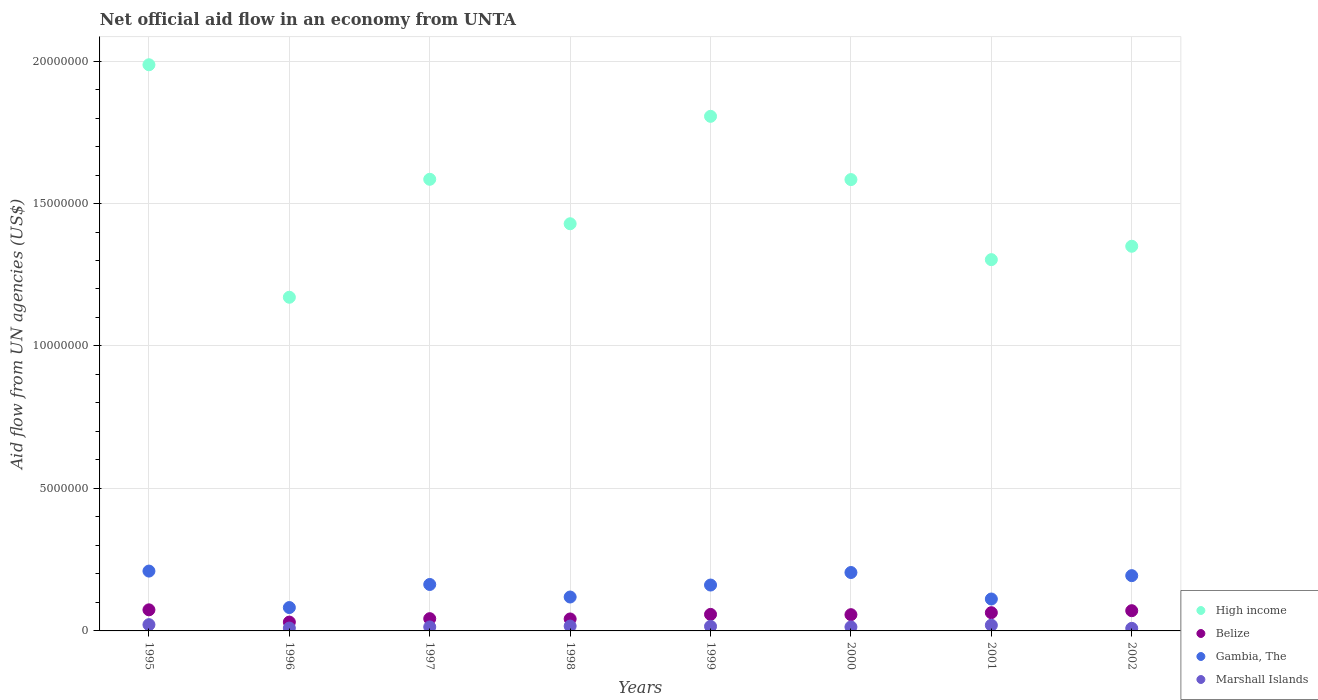How many different coloured dotlines are there?
Offer a terse response. 4. Is the number of dotlines equal to the number of legend labels?
Your answer should be very brief. Yes. What is the net official aid flow in Marshall Islands in 2000?
Provide a short and direct response. 1.40e+05. Across all years, what is the maximum net official aid flow in Gambia, The?
Give a very brief answer. 2.10e+06. Across all years, what is the minimum net official aid flow in Gambia, The?
Your answer should be compact. 8.20e+05. In which year was the net official aid flow in Gambia, The maximum?
Provide a succinct answer. 1995. What is the total net official aid flow in Marshall Islands in the graph?
Keep it short and to the point. 1.22e+06. What is the difference between the net official aid flow in High income in 1995 and that in 2001?
Keep it short and to the point. 6.84e+06. What is the difference between the net official aid flow in Gambia, The in 2002 and the net official aid flow in Belize in 1995?
Provide a short and direct response. 1.20e+06. What is the average net official aid flow in High income per year?
Offer a terse response. 1.53e+07. In the year 2002, what is the difference between the net official aid flow in Marshall Islands and net official aid flow in Gambia, The?
Your answer should be compact. -1.85e+06. What is the ratio of the net official aid flow in Marshall Islands in 1996 to that in 1997?
Provide a short and direct response. 0.71. What is the difference between the highest and the lowest net official aid flow in Marshall Islands?
Provide a succinct answer. 1.30e+05. Is the sum of the net official aid flow in Marshall Islands in 1996 and 1999 greater than the maximum net official aid flow in Gambia, The across all years?
Your response must be concise. No. Is it the case that in every year, the sum of the net official aid flow in High income and net official aid flow in Belize  is greater than the net official aid flow in Marshall Islands?
Offer a very short reply. Yes. Does the net official aid flow in High income monotonically increase over the years?
Your answer should be very brief. No. Is the net official aid flow in Belize strictly greater than the net official aid flow in Marshall Islands over the years?
Offer a terse response. Yes. Is the net official aid flow in Belize strictly less than the net official aid flow in Gambia, The over the years?
Ensure brevity in your answer.  Yes. How many dotlines are there?
Keep it short and to the point. 4. How many years are there in the graph?
Offer a terse response. 8. What is the difference between two consecutive major ticks on the Y-axis?
Provide a short and direct response. 5.00e+06. Does the graph contain grids?
Keep it short and to the point. Yes. What is the title of the graph?
Your answer should be compact. Net official aid flow in an economy from UNTA. What is the label or title of the X-axis?
Ensure brevity in your answer.  Years. What is the label or title of the Y-axis?
Provide a succinct answer. Aid flow from UN agencies (US$). What is the Aid flow from UN agencies (US$) in High income in 1995?
Make the answer very short. 1.99e+07. What is the Aid flow from UN agencies (US$) in Belize in 1995?
Offer a terse response. 7.40e+05. What is the Aid flow from UN agencies (US$) of Gambia, The in 1995?
Your answer should be very brief. 2.10e+06. What is the Aid flow from UN agencies (US$) in Marshall Islands in 1995?
Offer a terse response. 2.20e+05. What is the Aid flow from UN agencies (US$) in High income in 1996?
Provide a short and direct response. 1.17e+07. What is the Aid flow from UN agencies (US$) of Belize in 1996?
Provide a succinct answer. 3.10e+05. What is the Aid flow from UN agencies (US$) of Gambia, The in 1996?
Your answer should be compact. 8.20e+05. What is the Aid flow from UN agencies (US$) in High income in 1997?
Give a very brief answer. 1.58e+07. What is the Aid flow from UN agencies (US$) in Belize in 1997?
Provide a succinct answer. 4.30e+05. What is the Aid flow from UN agencies (US$) of Gambia, The in 1997?
Offer a terse response. 1.63e+06. What is the Aid flow from UN agencies (US$) of Marshall Islands in 1997?
Your response must be concise. 1.40e+05. What is the Aid flow from UN agencies (US$) in High income in 1998?
Your answer should be very brief. 1.43e+07. What is the Aid flow from UN agencies (US$) in Gambia, The in 1998?
Offer a very short reply. 1.19e+06. What is the Aid flow from UN agencies (US$) of High income in 1999?
Provide a succinct answer. 1.81e+07. What is the Aid flow from UN agencies (US$) in Belize in 1999?
Keep it short and to the point. 5.80e+05. What is the Aid flow from UN agencies (US$) of Gambia, The in 1999?
Ensure brevity in your answer.  1.61e+06. What is the Aid flow from UN agencies (US$) in Marshall Islands in 1999?
Provide a short and direct response. 1.60e+05. What is the Aid flow from UN agencies (US$) of High income in 2000?
Your answer should be compact. 1.58e+07. What is the Aid flow from UN agencies (US$) of Belize in 2000?
Offer a terse response. 5.70e+05. What is the Aid flow from UN agencies (US$) of Gambia, The in 2000?
Provide a succinct answer. 2.05e+06. What is the Aid flow from UN agencies (US$) of Marshall Islands in 2000?
Your answer should be compact. 1.40e+05. What is the Aid flow from UN agencies (US$) of High income in 2001?
Provide a succinct answer. 1.30e+07. What is the Aid flow from UN agencies (US$) of Belize in 2001?
Ensure brevity in your answer.  6.40e+05. What is the Aid flow from UN agencies (US$) of Gambia, The in 2001?
Give a very brief answer. 1.12e+06. What is the Aid flow from UN agencies (US$) in High income in 2002?
Give a very brief answer. 1.35e+07. What is the Aid flow from UN agencies (US$) of Belize in 2002?
Provide a succinct answer. 7.10e+05. What is the Aid flow from UN agencies (US$) of Gambia, The in 2002?
Ensure brevity in your answer.  1.94e+06. Across all years, what is the maximum Aid flow from UN agencies (US$) of High income?
Provide a short and direct response. 1.99e+07. Across all years, what is the maximum Aid flow from UN agencies (US$) of Belize?
Your answer should be very brief. 7.40e+05. Across all years, what is the maximum Aid flow from UN agencies (US$) of Gambia, The?
Provide a short and direct response. 2.10e+06. Across all years, what is the maximum Aid flow from UN agencies (US$) of Marshall Islands?
Keep it short and to the point. 2.20e+05. Across all years, what is the minimum Aid flow from UN agencies (US$) in High income?
Offer a terse response. 1.17e+07. Across all years, what is the minimum Aid flow from UN agencies (US$) in Gambia, The?
Keep it short and to the point. 8.20e+05. What is the total Aid flow from UN agencies (US$) in High income in the graph?
Your response must be concise. 1.22e+08. What is the total Aid flow from UN agencies (US$) in Belize in the graph?
Your answer should be compact. 4.40e+06. What is the total Aid flow from UN agencies (US$) in Gambia, The in the graph?
Make the answer very short. 1.25e+07. What is the total Aid flow from UN agencies (US$) in Marshall Islands in the graph?
Provide a succinct answer. 1.22e+06. What is the difference between the Aid flow from UN agencies (US$) of High income in 1995 and that in 1996?
Offer a terse response. 8.16e+06. What is the difference between the Aid flow from UN agencies (US$) of Gambia, The in 1995 and that in 1996?
Offer a very short reply. 1.28e+06. What is the difference between the Aid flow from UN agencies (US$) in Marshall Islands in 1995 and that in 1996?
Make the answer very short. 1.20e+05. What is the difference between the Aid flow from UN agencies (US$) in High income in 1995 and that in 1997?
Your answer should be compact. 4.02e+06. What is the difference between the Aid flow from UN agencies (US$) in Belize in 1995 and that in 1997?
Offer a very short reply. 3.10e+05. What is the difference between the Aid flow from UN agencies (US$) of Marshall Islands in 1995 and that in 1997?
Provide a short and direct response. 8.00e+04. What is the difference between the Aid flow from UN agencies (US$) of High income in 1995 and that in 1998?
Your response must be concise. 5.58e+06. What is the difference between the Aid flow from UN agencies (US$) of Gambia, The in 1995 and that in 1998?
Keep it short and to the point. 9.10e+05. What is the difference between the Aid flow from UN agencies (US$) of High income in 1995 and that in 1999?
Your answer should be very brief. 1.81e+06. What is the difference between the Aid flow from UN agencies (US$) of Belize in 1995 and that in 1999?
Provide a succinct answer. 1.60e+05. What is the difference between the Aid flow from UN agencies (US$) of High income in 1995 and that in 2000?
Ensure brevity in your answer.  4.03e+06. What is the difference between the Aid flow from UN agencies (US$) of Gambia, The in 1995 and that in 2000?
Offer a terse response. 5.00e+04. What is the difference between the Aid flow from UN agencies (US$) in Marshall Islands in 1995 and that in 2000?
Provide a short and direct response. 8.00e+04. What is the difference between the Aid flow from UN agencies (US$) of High income in 1995 and that in 2001?
Your answer should be compact. 6.84e+06. What is the difference between the Aid flow from UN agencies (US$) of Gambia, The in 1995 and that in 2001?
Give a very brief answer. 9.80e+05. What is the difference between the Aid flow from UN agencies (US$) of Marshall Islands in 1995 and that in 2001?
Give a very brief answer. 2.00e+04. What is the difference between the Aid flow from UN agencies (US$) of High income in 1995 and that in 2002?
Your response must be concise. 6.37e+06. What is the difference between the Aid flow from UN agencies (US$) in Belize in 1995 and that in 2002?
Your answer should be compact. 3.00e+04. What is the difference between the Aid flow from UN agencies (US$) in High income in 1996 and that in 1997?
Provide a short and direct response. -4.14e+06. What is the difference between the Aid flow from UN agencies (US$) of Gambia, The in 1996 and that in 1997?
Give a very brief answer. -8.10e+05. What is the difference between the Aid flow from UN agencies (US$) of Marshall Islands in 1996 and that in 1997?
Ensure brevity in your answer.  -4.00e+04. What is the difference between the Aid flow from UN agencies (US$) of High income in 1996 and that in 1998?
Offer a terse response. -2.58e+06. What is the difference between the Aid flow from UN agencies (US$) in Gambia, The in 1996 and that in 1998?
Give a very brief answer. -3.70e+05. What is the difference between the Aid flow from UN agencies (US$) in High income in 1996 and that in 1999?
Your response must be concise. -6.35e+06. What is the difference between the Aid flow from UN agencies (US$) in Belize in 1996 and that in 1999?
Your answer should be compact. -2.70e+05. What is the difference between the Aid flow from UN agencies (US$) in Gambia, The in 1996 and that in 1999?
Offer a very short reply. -7.90e+05. What is the difference between the Aid flow from UN agencies (US$) in Marshall Islands in 1996 and that in 1999?
Your response must be concise. -6.00e+04. What is the difference between the Aid flow from UN agencies (US$) in High income in 1996 and that in 2000?
Give a very brief answer. -4.13e+06. What is the difference between the Aid flow from UN agencies (US$) in Belize in 1996 and that in 2000?
Provide a short and direct response. -2.60e+05. What is the difference between the Aid flow from UN agencies (US$) of Gambia, The in 1996 and that in 2000?
Your response must be concise. -1.23e+06. What is the difference between the Aid flow from UN agencies (US$) in Marshall Islands in 1996 and that in 2000?
Your answer should be compact. -4.00e+04. What is the difference between the Aid flow from UN agencies (US$) of High income in 1996 and that in 2001?
Your answer should be very brief. -1.32e+06. What is the difference between the Aid flow from UN agencies (US$) in Belize in 1996 and that in 2001?
Make the answer very short. -3.30e+05. What is the difference between the Aid flow from UN agencies (US$) of Gambia, The in 1996 and that in 2001?
Offer a terse response. -3.00e+05. What is the difference between the Aid flow from UN agencies (US$) of Marshall Islands in 1996 and that in 2001?
Offer a terse response. -1.00e+05. What is the difference between the Aid flow from UN agencies (US$) of High income in 1996 and that in 2002?
Your answer should be compact. -1.79e+06. What is the difference between the Aid flow from UN agencies (US$) in Belize in 1996 and that in 2002?
Make the answer very short. -4.00e+05. What is the difference between the Aid flow from UN agencies (US$) of Gambia, The in 1996 and that in 2002?
Your answer should be very brief. -1.12e+06. What is the difference between the Aid flow from UN agencies (US$) in Marshall Islands in 1996 and that in 2002?
Ensure brevity in your answer.  10000. What is the difference between the Aid flow from UN agencies (US$) in High income in 1997 and that in 1998?
Offer a very short reply. 1.56e+06. What is the difference between the Aid flow from UN agencies (US$) of High income in 1997 and that in 1999?
Offer a very short reply. -2.21e+06. What is the difference between the Aid flow from UN agencies (US$) of Belize in 1997 and that in 1999?
Provide a short and direct response. -1.50e+05. What is the difference between the Aid flow from UN agencies (US$) in High income in 1997 and that in 2000?
Offer a terse response. 10000. What is the difference between the Aid flow from UN agencies (US$) of Belize in 1997 and that in 2000?
Your answer should be compact. -1.40e+05. What is the difference between the Aid flow from UN agencies (US$) in Gambia, The in 1997 and that in 2000?
Ensure brevity in your answer.  -4.20e+05. What is the difference between the Aid flow from UN agencies (US$) in High income in 1997 and that in 2001?
Provide a short and direct response. 2.82e+06. What is the difference between the Aid flow from UN agencies (US$) of Belize in 1997 and that in 2001?
Ensure brevity in your answer.  -2.10e+05. What is the difference between the Aid flow from UN agencies (US$) of Gambia, The in 1997 and that in 2001?
Keep it short and to the point. 5.10e+05. What is the difference between the Aid flow from UN agencies (US$) in High income in 1997 and that in 2002?
Give a very brief answer. 2.35e+06. What is the difference between the Aid flow from UN agencies (US$) of Belize in 1997 and that in 2002?
Provide a short and direct response. -2.80e+05. What is the difference between the Aid flow from UN agencies (US$) in Gambia, The in 1997 and that in 2002?
Ensure brevity in your answer.  -3.10e+05. What is the difference between the Aid flow from UN agencies (US$) in High income in 1998 and that in 1999?
Your answer should be compact. -3.77e+06. What is the difference between the Aid flow from UN agencies (US$) of Belize in 1998 and that in 1999?
Your response must be concise. -1.60e+05. What is the difference between the Aid flow from UN agencies (US$) of Gambia, The in 1998 and that in 1999?
Offer a very short reply. -4.20e+05. What is the difference between the Aid flow from UN agencies (US$) of Marshall Islands in 1998 and that in 1999?
Make the answer very short. 10000. What is the difference between the Aid flow from UN agencies (US$) in High income in 1998 and that in 2000?
Give a very brief answer. -1.55e+06. What is the difference between the Aid flow from UN agencies (US$) in Belize in 1998 and that in 2000?
Provide a succinct answer. -1.50e+05. What is the difference between the Aid flow from UN agencies (US$) of Gambia, The in 1998 and that in 2000?
Your response must be concise. -8.60e+05. What is the difference between the Aid flow from UN agencies (US$) in Marshall Islands in 1998 and that in 2000?
Provide a short and direct response. 3.00e+04. What is the difference between the Aid flow from UN agencies (US$) in High income in 1998 and that in 2001?
Make the answer very short. 1.26e+06. What is the difference between the Aid flow from UN agencies (US$) of Belize in 1998 and that in 2001?
Provide a short and direct response. -2.20e+05. What is the difference between the Aid flow from UN agencies (US$) in Marshall Islands in 1998 and that in 2001?
Offer a terse response. -3.00e+04. What is the difference between the Aid flow from UN agencies (US$) in High income in 1998 and that in 2002?
Your response must be concise. 7.90e+05. What is the difference between the Aid flow from UN agencies (US$) in Gambia, The in 1998 and that in 2002?
Provide a short and direct response. -7.50e+05. What is the difference between the Aid flow from UN agencies (US$) of High income in 1999 and that in 2000?
Offer a terse response. 2.22e+06. What is the difference between the Aid flow from UN agencies (US$) of Gambia, The in 1999 and that in 2000?
Ensure brevity in your answer.  -4.40e+05. What is the difference between the Aid flow from UN agencies (US$) of Marshall Islands in 1999 and that in 2000?
Provide a succinct answer. 2.00e+04. What is the difference between the Aid flow from UN agencies (US$) of High income in 1999 and that in 2001?
Make the answer very short. 5.03e+06. What is the difference between the Aid flow from UN agencies (US$) in Belize in 1999 and that in 2001?
Your answer should be compact. -6.00e+04. What is the difference between the Aid flow from UN agencies (US$) in Marshall Islands in 1999 and that in 2001?
Your answer should be compact. -4.00e+04. What is the difference between the Aid flow from UN agencies (US$) of High income in 1999 and that in 2002?
Your answer should be very brief. 4.56e+06. What is the difference between the Aid flow from UN agencies (US$) of Gambia, The in 1999 and that in 2002?
Provide a short and direct response. -3.30e+05. What is the difference between the Aid flow from UN agencies (US$) in High income in 2000 and that in 2001?
Your response must be concise. 2.81e+06. What is the difference between the Aid flow from UN agencies (US$) in Belize in 2000 and that in 2001?
Offer a very short reply. -7.00e+04. What is the difference between the Aid flow from UN agencies (US$) in Gambia, The in 2000 and that in 2001?
Ensure brevity in your answer.  9.30e+05. What is the difference between the Aid flow from UN agencies (US$) of Marshall Islands in 2000 and that in 2001?
Provide a succinct answer. -6.00e+04. What is the difference between the Aid flow from UN agencies (US$) in High income in 2000 and that in 2002?
Provide a short and direct response. 2.34e+06. What is the difference between the Aid flow from UN agencies (US$) of Belize in 2000 and that in 2002?
Your answer should be compact. -1.40e+05. What is the difference between the Aid flow from UN agencies (US$) in Gambia, The in 2000 and that in 2002?
Provide a succinct answer. 1.10e+05. What is the difference between the Aid flow from UN agencies (US$) in High income in 2001 and that in 2002?
Your response must be concise. -4.70e+05. What is the difference between the Aid flow from UN agencies (US$) in Gambia, The in 2001 and that in 2002?
Make the answer very short. -8.20e+05. What is the difference between the Aid flow from UN agencies (US$) of Marshall Islands in 2001 and that in 2002?
Your answer should be compact. 1.10e+05. What is the difference between the Aid flow from UN agencies (US$) in High income in 1995 and the Aid flow from UN agencies (US$) in Belize in 1996?
Your answer should be compact. 1.96e+07. What is the difference between the Aid flow from UN agencies (US$) in High income in 1995 and the Aid flow from UN agencies (US$) in Gambia, The in 1996?
Give a very brief answer. 1.90e+07. What is the difference between the Aid flow from UN agencies (US$) in High income in 1995 and the Aid flow from UN agencies (US$) in Marshall Islands in 1996?
Keep it short and to the point. 1.98e+07. What is the difference between the Aid flow from UN agencies (US$) of Belize in 1995 and the Aid flow from UN agencies (US$) of Gambia, The in 1996?
Make the answer very short. -8.00e+04. What is the difference between the Aid flow from UN agencies (US$) of Belize in 1995 and the Aid flow from UN agencies (US$) of Marshall Islands in 1996?
Ensure brevity in your answer.  6.40e+05. What is the difference between the Aid flow from UN agencies (US$) of High income in 1995 and the Aid flow from UN agencies (US$) of Belize in 1997?
Provide a succinct answer. 1.94e+07. What is the difference between the Aid flow from UN agencies (US$) in High income in 1995 and the Aid flow from UN agencies (US$) in Gambia, The in 1997?
Provide a succinct answer. 1.82e+07. What is the difference between the Aid flow from UN agencies (US$) of High income in 1995 and the Aid flow from UN agencies (US$) of Marshall Islands in 1997?
Your answer should be compact. 1.97e+07. What is the difference between the Aid flow from UN agencies (US$) of Belize in 1995 and the Aid flow from UN agencies (US$) of Gambia, The in 1997?
Give a very brief answer. -8.90e+05. What is the difference between the Aid flow from UN agencies (US$) in Belize in 1995 and the Aid flow from UN agencies (US$) in Marshall Islands in 1997?
Offer a terse response. 6.00e+05. What is the difference between the Aid flow from UN agencies (US$) in Gambia, The in 1995 and the Aid flow from UN agencies (US$) in Marshall Islands in 1997?
Your response must be concise. 1.96e+06. What is the difference between the Aid flow from UN agencies (US$) of High income in 1995 and the Aid flow from UN agencies (US$) of Belize in 1998?
Ensure brevity in your answer.  1.94e+07. What is the difference between the Aid flow from UN agencies (US$) in High income in 1995 and the Aid flow from UN agencies (US$) in Gambia, The in 1998?
Ensure brevity in your answer.  1.87e+07. What is the difference between the Aid flow from UN agencies (US$) of High income in 1995 and the Aid flow from UN agencies (US$) of Marshall Islands in 1998?
Offer a terse response. 1.97e+07. What is the difference between the Aid flow from UN agencies (US$) of Belize in 1995 and the Aid flow from UN agencies (US$) of Gambia, The in 1998?
Your response must be concise. -4.50e+05. What is the difference between the Aid flow from UN agencies (US$) in Belize in 1995 and the Aid flow from UN agencies (US$) in Marshall Islands in 1998?
Make the answer very short. 5.70e+05. What is the difference between the Aid flow from UN agencies (US$) of Gambia, The in 1995 and the Aid flow from UN agencies (US$) of Marshall Islands in 1998?
Provide a short and direct response. 1.93e+06. What is the difference between the Aid flow from UN agencies (US$) in High income in 1995 and the Aid flow from UN agencies (US$) in Belize in 1999?
Ensure brevity in your answer.  1.93e+07. What is the difference between the Aid flow from UN agencies (US$) of High income in 1995 and the Aid flow from UN agencies (US$) of Gambia, The in 1999?
Give a very brief answer. 1.83e+07. What is the difference between the Aid flow from UN agencies (US$) of High income in 1995 and the Aid flow from UN agencies (US$) of Marshall Islands in 1999?
Make the answer very short. 1.97e+07. What is the difference between the Aid flow from UN agencies (US$) of Belize in 1995 and the Aid flow from UN agencies (US$) of Gambia, The in 1999?
Make the answer very short. -8.70e+05. What is the difference between the Aid flow from UN agencies (US$) in Belize in 1995 and the Aid flow from UN agencies (US$) in Marshall Islands in 1999?
Make the answer very short. 5.80e+05. What is the difference between the Aid flow from UN agencies (US$) of Gambia, The in 1995 and the Aid flow from UN agencies (US$) of Marshall Islands in 1999?
Offer a very short reply. 1.94e+06. What is the difference between the Aid flow from UN agencies (US$) in High income in 1995 and the Aid flow from UN agencies (US$) in Belize in 2000?
Your answer should be very brief. 1.93e+07. What is the difference between the Aid flow from UN agencies (US$) in High income in 1995 and the Aid flow from UN agencies (US$) in Gambia, The in 2000?
Provide a succinct answer. 1.78e+07. What is the difference between the Aid flow from UN agencies (US$) in High income in 1995 and the Aid flow from UN agencies (US$) in Marshall Islands in 2000?
Give a very brief answer. 1.97e+07. What is the difference between the Aid flow from UN agencies (US$) in Belize in 1995 and the Aid flow from UN agencies (US$) in Gambia, The in 2000?
Give a very brief answer. -1.31e+06. What is the difference between the Aid flow from UN agencies (US$) of Belize in 1995 and the Aid flow from UN agencies (US$) of Marshall Islands in 2000?
Make the answer very short. 6.00e+05. What is the difference between the Aid flow from UN agencies (US$) in Gambia, The in 1995 and the Aid flow from UN agencies (US$) in Marshall Islands in 2000?
Make the answer very short. 1.96e+06. What is the difference between the Aid flow from UN agencies (US$) of High income in 1995 and the Aid flow from UN agencies (US$) of Belize in 2001?
Your response must be concise. 1.92e+07. What is the difference between the Aid flow from UN agencies (US$) of High income in 1995 and the Aid flow from UN agencies (US$) of Gambia, The in 2001?
Keep it short and to the point. 1.88e+07. What is the difference between the Aid flow from UN agencies (US$) of High income in 1995 and the Aid flow from UN agencies (US$) of Marshall Islands in 2001?
Give a very brief answer. 1.97e+07. What is the difference between the Aid flow from UN agencies (US$) of Belize in 1995 and the Aid flow from UN agencies (US$) of Gambia, The in 2001?
Your response must be concise. -3.80e+05. What is the difference between the Aid flow from UN agencies (US$) of Belize in 1995 and the Aid flow from UN agencies (US$) of Marshall Islands in 2001?
Ensure brevity in your answer.  5.40e+05. What is the difference between the Aid flow from UN agencies (US$) of Gambia, The in 1995 and the Aid flow from UN agencies (US$) of Marshall Islands in 2001?
Make the answer very short. 1.90e+06. What is the difference between the Aid flow from UN agencies (US$) in High income in 1995 and the Aid flow from UN agencies (US$) in Belize in 2002?
Offer a terse response. 1.92e+07. What is the difference between the Aid flow from UN agencies (US$) in High income in 1995 and the Aid flow from UN agencies (US$) in Gambia, The in 2002?
Ensure brevity in your answer.  1.79e+07. What is the difference between the Aid flow from UN agencies (US$) in High income in 1995 and the Aid flow from UN agencies (US$) in Marshall Islands in 2002?
Your response must be concise. 1.98e+07. What is the difference between the Aid flow from UN agencies (US$) in Belize in 1995 and the Aid flow from UN agencies (US$) in Gambia, The in 2002?
Provide a succinct answer. -1.20e+06. What is the difference between the Aid flow from UN agencies (US$) in Belize in 1995 and the Aid flow from UN agencies (US$) in Marshall Islands in 2002?
Keep it short and to the point. 6.50e+05. What is the difference between the Aid flow from UN agencies (US$) of Gambia, The in 1995 and the Aid flow from UN agencies (US$) of Marshall Islands in 2002?
Offer a very short reply. 2.01e+06. What is the difference between the Aid flow from UN agencies (US$) of High income in 1996 and the Aid flow from UN agencies (US$) of Belize in 1997?
Provide a short and direct response. 1.13e+07. What is the difference between the Aid flow from UN agencies (US$) of High income in 1996 and the Aid flow from UN agencies (US$) of Gambia, The in 1997?
Provide a succinct answer. 1.01e+07. What is the difference between the Aid flow from UN agencies (US$) of High income in 1996 and the Aid flow from UN agencies (US$) of Marshall Islands in 1997?
Offer a very short reply. 1.16e+07. What is the difference between the Aid flow from UN agencies (US$) of Belize in 1996 and the Aid flow from UN agencies (US$) of Gambia, The in 1997?
Your response must be concise. -1.32e+06. What is the difference between the Aid flow from UN agencies (US$) in Belize in 1996 and the Aid flow from UN agencies (US$) in Marshall Islands in 1997?
Your answer should be very brief. 1.70e+05. What is the difference between the Aid flow from UN agencies (US$) of Gambia, The in 1996 and the Aid flow from UN agencies (US$) of Marshall Islands in 1997?
Ensure brevity in your answer.  6.80e+05. What is the difference between the Aid flow from UN agencies (US$) of High income in 1996 and the Aid flow from UN agencies (US$) of Belize in 1998?
Provide a short and direct response. 1.13e+07. What is the difference between the Aid flow from UN agencies (US$) of High income in 1996 and the Aid flow from UN agencies (US$) of Gambia, The in 1998?
Your answer should be very brief. 1.05e+07. What is the difference between the Aid flow from UN agencies (US$) in High income in 1996 and the Aid flow from UN agencies (US$) in Marshall Islands in 1998?
Provide a short and direct response. 1.15e+07. What is the difference between the Aid flow from UN agencies (US$) in Belize in 1996 and the Aid flow from UN agencies (US$) in Gambia, The in 1998?
Ensure brevity in your answer.  -8.80e+05. What is the difference between the Aid flow from UN agencies (US$) in Belize in 1996 and the Aid flow from UN agencies (US$) in Marshall Islands in 1998?
Offer a terse response. 1.40e+05. What is the difference between the Aid flow from UN agencies (US$) in Gambia, The in 1996 and the Aid flow from UN agencies (US$) in Marshall Islands in 1998?
Offer a very short reply. 6.50e+05. What is the difference between the Aid flow from UN agencies (US$) in High income in 1996 and the Aid flow from UN agencies (US$) in Belize in 1999?
Give a very brief answer. 1.11e+07. What is the difference between the Aid flow from UN agencies (US$) in High income in 1996 and the Aid flow from UN agencies (US$) in Gambia, The in 1999?
Keep it short and to the point. 1.01e+07. What is the difference between the Aid flow from UN agencies (US$) of High income in 1996 and the Aid flow from UN agencies (US$) of Marshall Islands in 1999?
Offer a very short reply. 1.16e+07. What is the difference between the Aid flow from UN agencies (US$) of Belize in 1996 and the Aid flow from UN agencies (US$) of Gambia, The in 1999?
Your answer should be very brief. -1.30e+06. What is the difference between the Aid flow from UN agencies (US$) of Belize in 1996 and the Aid flow from UN agencies (US$) of Marshall Islands in 1999?
Provide a short and direct response. 1.50e+05. What is the difference between the Aid flow from UN agencies (US$) of High income in 1996 and the Aid flow from UN agencies (US$) of Belize in 2000?
Provide a short and direct response. 1.11e+07. What is the difference between the Aid flow from UN agencies (US$) of High income in 1996 and the Aid flow from UN agencies (US$) of Gambia, The in 2000?
Your answer should be very brief. 9.66e+06. What is the difference between the Aid flow from UN agencies (US$) in High income in 1996 and the Aid flow from UN agencies (US$) in Marshall Islands in 2000?
Your response must be concise. 1.16e+07. What is the difference between the Aid flow from UN agencies (US$) of Belize in 1996 and the Aid flow from UN agencies (US$) of Gambia, The in 2000?
Keep it short and to the point. -1.74e+06. What is the difference between the Aid flow from UN agencies (US$) of Gambia, The in 1996 and the Aid flow from UN agencies (US$) of Marshall Islands in 2000?
Offer a very short reply. 6.80e+05. What is the difference between the Aid flow from UN agencies (US$) of High income in 1996 and the Aid flow from UN agencies (US$) of Belize in 2001?
Provide a succinct answer. 1.11e+07. What is the difference between the Aid flow from UN agencies (US$) in High income in 1996 and the Aid flow from UN agencies (US$) in Gambia, The in 2001?
Your answer should be very brief. 1.06e+07. What is the difference between the Aid flow from UN agencies (US$) of High income in 1996 and the Aid flow from UN agencies (US$) of Marshall Islands in 2001?
Keep it short and to the point. 1.15e+07. What is the difference between the Aid flow from UN agencies (US$) of Belize in 1996 and the Aid flow from UN agencies (US$) of Gambia, The in 2001?
Offer a terse response. -8.10e+05. What is the difference between the Aid flow from UN agencies (US$) of Belize in 1996 and the Aid flow from UN agencies (US$) of Marshall Islands in 2001?
Provide a short and direct response. 1.10e+05. What is the difference between the Aid flow from UN agencies (US$) of Gambia, The in 1996 and the Aid flow from UN agencies (US$) of Marshall Islands in 2001?
Offer a very short reply. 6.20e+05. What is the difference between the Aid flow from UN agencies (US$) in High income in 1996 and the Aid flow from UN agencies (US$) in Belize in 2002?
Offer a terse response. 1.10e+07. What is the difference between the Aid flow from UN agencies (US$) of High income in 1996 and the Aid flow from UN agencies (US$) of Gambia, The in 2002?
Ensure brevity in your answer.  9.77e+06. What is the difference between the Aid flow from UN agencies (US$) of High income in 1996 and the Aid flow from UN agencies (US$) of Marshall Islands in 2002?
Provide a succinct answer. 1.16e+07. What is the difference between the Aid flow from UN agencies (US$) of Belize in 1996 and the Aid flow from UN agencies (US$) of Gambia, The in 2002?
Your answer should be very brief. -1.63e+06. What is the difference between the Aid flow from UN agencies (US$) of Gambia, The in 1996 and the Aid flow from UN agencies (US$) of Marshall Islands in 2002?
Make the answer very short. 7.30e+05. What is the difference between the Aid flow from UN agencies (US$) in High income in 1997 and the Aid flow from UN agencies (US$) in Belize in 1998?
Your response must be concise. 1.54e+07. What is the difference between the Aid flow from UN agencies (US$) in High income in 1997 and the Aid flow from UN agencies (US$) in Gambia, The in 1998?
Offer a terse response. 1.47e+07. What is the difference between the Aid flow from UN agencies (US$) of High income in 1997 and the Aid flow from UN agencies (US$) of Marshall Islands in 1998?
Give a very brief answer. 1.57e+07. What is the difference between the Aid flow from UN agencies (US$) in Belize in 1997 and the Aid flow from UN agencies (US$) in Gambia, The in 1998?
Your answer should be compact. -7.60e+05. What is the difference between the Aid flow from UN agencies (US$) of Gambia, The in 1997 and the Aid flow from UN agencies (US$) of Marshall Islands in 1998?
Keep it short and to the point. 1.46e+06. What is the difference between the Aid flow from UN agencies (US$) of High income in 1997 and the Aid flow from UN agencies (US$) of Belize in 1999?
Offer a terse response. 1.53e+07. What is the difference between the Aid flow from UN agencies (US$) of High income in 1997 and the Aid flow from UN agencies (US$) of Gambia, The in 1999?
Offer a terse response. 1.42e+07. What is the difference between the Aid flow from UN agencies (US$) of High income in 1997 and the Aid flow from UN agencies (US$) of Marshall Islands in 1999?
Keep it short and to the point. 1.57e+07. What is the difference between the Aid flow from UN agencies (US$) of Belize in 1997 and the Aid flow from UN agencies (US$) of Gambia, The in 1999?
Your answer should be very brief. -1.18e+06. What is the difference between the Aid flow from UN agencies (US$) in Belize in 1997 and the Aid flow from UN agencies (US$) in Marshall Islands in 1999?
Provide a succinct answer. 2.70e+05. What is the difference between the Aid flow from UN agencies (US$) in Gambia, The in 1997 and the Aid flow from UN agencies (US$) in Marshall Islands in 1999?
Offer a terse response. 1.47e+06. What is the difference between the Aid flow from UN agencies (US$) in High income in 1997 and the Aid flow from UN agencies (US$) in Belize in 2000?
Your answer should be compact. 1.53e+07. What is the difference between the Aid flow from UN agencies (US$) of High income in 1997 and the Aid flow from UN agencies (US$) of Gambia, The in 2000?
Offer a terse response. 1.38e+07. What is the difference between the Aid flow from UN agencies (US$) of High income in 1997 and the Aid flow from UN agencies (US$) of Marshall Islands in 2000?
Offer a very short reply. 1.57e+07. What is the difference between the Aid flow from UN agencies (US$) of Belize in 1997 and the Aid flow from UN agencies (US$) of Gambia, The in 2000?
Make the answer very short. -1.62e+06. What is the difference between the Aid flow from UN agencies (US$) in Belize in 1997 and the Aid flow from UN agencies (US$) in Marshall Islands in 2000?
Provide a succinct answer. 2.90e+05. What is the difference between the Aid flow from UN agencies (US$) of Gambia, The in 1997 and the Aid flow from UN agencies (US$) of Marshall Islands in 2000?
Provide a succinct answer. 1.49e+06. What is the difference between the Aid flow from UN agencies (US$) of High income in 1997 and the Aid flow from UN agencies (US$) of Belize in 2001?
Your answer should be very brief. 1.52e+07. What is the difference between the Aid flow from UN agencies (US$) of High income in 1997 and the Aid flow from UN agencies (US$) of Gambia, The in 2001?
Offer a terse response. 1.47e+07. What is the difference between the Aid flow from UN agencies (US$) in High income in 1997 and the Aid flow from UN agencies (US$) in Marshall Islands in 2001?
Offer a very short reply. 1.56e+07. What is the difference between the Aid flow from UN agencies (US$) in Belize in 1997 and the Aid flow from UN agencies (US$) in Gambia, The in 2001?
Provide a short and direct response. -6.90e+05. What is the difference between the Aid flow from UN agencies (US$) in Gambia, The in 1997 and the Aid flow from UN agencies (US$) in Marshall Islands in 2001?
Keep it short and to the point. 1.43e+06. What is the difference between the Aid flow from UN agencies (US$) of High income in 1997 and the Aid flow from UN agencies (US$) of Belize in 2002?
Make the answer very short. 1.51e+07. What is the difference between the Aid flow from UN agencies (US$) in High income in 1997 and the Aid flow from UN agencies (US$) in Gambia, The in 2002?
Provide a succinct answer. 1.39e+07. What is the difference between the Aid flow from UN agencies (US$) in High income in 1997 and the Aid flow from UN agencies (US$) in Marshall Islands in 2002?
Offer a terse response. 1.58e+07. What is the difference between the Aid flow from UN agencies (US$) in Belize in 1997 and the Aid flow from UN agencies (US$) in Gambia, The in 2002?
Ensure brevity in your answer.  -1.51e+06. What is the difference between the Aid flow from UN agencies (US$) in Belize in 1997 and the Aid flow from UN agencies (US$) in Marshall Islands in 2002?
Provide a short and direct response. 3.40e+05. What is the difference between the Aid flow from UN agencies (US$) in Gambia, The in 1997 and the Aid flow from UN agencies (US$) in Marshall Islands in 2002?
Your response must be concise. 1.54e+06. What is the difference between the Aid flow from UN agencies (US$) in High income in 1998 and the Aid flow from UN agencies (US$) in Belize in 1999?
Your answer should be compact. 1.37e+07. What is the difference between the Aid flow from UN agencies (US$) of High income in 1998 and the Aid flow from UN agencies (US$) of Gambia, The in 1999?
Ensure brevity in your answer.  1.27e+07. What is the difference between the Aid flow from UN agencies (US$) in High income in 1998 and the Aid flow from UN agencies (US$) in Marshall Islands in 1999?
Your answer should be very brief. 1.41e+07. What is the difference between the Aid flow from UN agencies (US$) of Belize in 1998 and the Aid flow from UN agencies (US$) of Gambia, The in 1999?
Ensure brevity in your answer.  -1.19e+06. What is the difference between the Aid flow from UN agencies (US$) of Gambia, The in 1998 and the Aid flow from UN agencies (US$) of Marshall Islands in 1999?
Provide a short and direct response. 1.03e+06. What is the difference between the Aid flow from UN agencies (US$) in High income in 1998 and the Aid flow from UN agencies (US$) in Belize in 2000?
Provide a succinct answer. 1.37e+07. What is the difference between the Aid flow from UN agencies (US$) of High income in 1998 and the Aid flow from UN agencies (US$) of Gambia, The in 2000?
Provide a succinct answer. 1.22e+07. What is the difference between the Aid flow from UN agencies (US$) in High income in 1998 and the Aid flow from UN agencies (US$) in Marshall Islands in 2000?
Make the answer very short. 1.42e+07. What is the difference between the Aid flow from UN agencies (US$) of Belize in 1998 and the Aid flow from UN agencies (US$) of Gambia, The in 2000?
Keep it short and to the point. -1.63e+06. What is the difference between the Aid flow from UN agencies (US$) of Gambia, The in 1998 and the Aid flow from UN agencies (US$) of Marshall Islands in 2000?
Give a very brief answer. 1.05e+06. What is the difference between the Aid flow from UN agencies (US$) in High income in 1998 and the Aid flow from UN agencies (US$) in Belize in 2001?
Give a very brief answer. 1.36e+07. What is the difference between the Aid flow from UN agencies (US$) of High income in 1998 and the Aid flow from UN agencies (US$) of Gambia, The in 2001?
Make the answer very short. 1.32e+07. What is the difference between the Aid flow from UN agencies (US$) in High income in 1998 and the Aid flow from UN agencies (US$) in Marshall Islands in 2001?
Ensure brevity in your answer.  1.41e+07. What is the difference between the Aid flow from UN agencies (US$) of Belize in 1998 and the Aid flow from UN agencies (US$) of Gambia, The in 2001?
Give a very brief answer. -7.00e+05. What is the difference between the Aid flow from UN agencies (US$) of Belize in 1998 and the Aid flow from UN agencies (US$) of Marshall Islands in 2001?
Your response must be concise. 2.20e+05. What is the difference between the Aid flow from UN agencies (US$) in Gambia, The in 1998 and the Aid flow from UN agencies (US$) in Marshall Islands in 2001?
Offer a terse response. 9.90e+05. What is the difference between the Aid flow from UN agencies (US$) of High income in 1998 and the Aid flow from UN agencies (US$) of Belize in 2002?
Keep it short and to the point. 1.36e+07. What is the difference between the Aid flow from UN agencies (US$) of High income in 1998 and the Aid flow from UN agencies (US$) of Gambia, The in 2002?
Ensure brevity in your answer.  1.24e+07. What is the difference between the Aid flow from UN agencies (US$) of High income in 1998 and the Aid flow from UN agencies (US$) of Marshall Islands in 2002?
Provide a short and direct response. 1.42e+07. What is the difference between the Aid flow from UN agencies (US$) in Belize in 1998 and the Aid flow from UN agencies (US$) in Gambia, The in 2002?
Provide a succinct answer. -1.52e+06. What is the difference between the Aid flow from UN agencies (US$) of Gambia, The in 1998 and the Aid flow from UN agencies (US$) of Marshall Islands in 2002?
Keep it short and to the point. 1.10e+06. What is the difference between the Aid flow from UN agencies (US$) in High income in 1999 and the Aid flow from UN agencies (US$) in Belize in 2000?
Your answer should be very brief. 1.75e+07. What is the difference between the Aid flow from UN agencies (US$) in High income in 1999 and the Aid flow from UN agencies (US$) in Gambia, The in 2000?
Offer a terse response. 1.60e+07. What is the difference between the Aid flow from UN agencies (US$) of High income in 1999 and the Aid flow from UN agencies (US$) of Marshall Islands in 2000?
Give a very brief answer. 1.79e+07. What is the difference between the Aid flow from UN agencies (US$) of Belize in 1999 and the Aid flow from UN agencies (US$) of Gambia, The in 2000?
Provide a short and direct response. -1.47e+06. What is the difference between the Aid flow from UN agencies (US$) in Gambia, The in 1999 and the Aid flow from UN agencies (US$) in Marshall Islands in 2000?
Make the answer very short. 1.47e+06. What is the difference between the Aid flow from UN agencies (US$) of High income in 1999 and the Aid flow from UN agencies (US$) of Belize in 2001?
Your response must be concise. 1.74e+07. What is the difference between the Aid flow from UN agencies (US$) of High income in 1999 and the Aid flow from UN agencies (US$) of Gambia, The in 2001?
Offer a terse response. 1.69e+07. What is the difference between the Aid flow from UN agencies (US$) in High income in 1999 and the Aid flow from UN agencies (US$) in Marshall Islands in 2001?
Your answer should be very brief. 1.79e+07. What is the difference between the Aid flow from UN agencies (US$) in Belize in 1999 and the Aid flow from UN agencies (US$) in Gambia, The in 2001?
Your answer should be very brief. -5.40e+05. What is the difference between the Aid flow from UN agencies (US$) of Gambia, The in 1999 and the Aid flow from UN agencies (US$) of Marshall Islands in 2001?
Your answer should be very brief. 1.41e+06. What is the difference between the Aid flow from UN agencies (US$) in High income in 1999 and the Aid flow from UN agencies (US$) in Belize in 2002?
Provide a short and direct response. 1.74e+07. What is the difference between the Aid flow from UN agencies (US$) of High income in 1999 and the Aid flow from UN agencies (US$) of Gambia, The in 2002?
Make the answer very short. 1.61e+07. What is the difference between the Aid flow from UN agencies (US$) in High income in 1999 and the Aid flow from UN agencies (US$) in Marshall Islands in 2002?
Ensure brevity in your answer.  1.80e+07. What is the difference between the Aid flow from UN agencies (US$) of Belize in 1999 and the Aid flow from UN agencies (US$) of Gambia, The in 2002?
Make the answer very short. -1.36e+06. What is the difference between the Aid flow from UN agencies (US$) in Gambia, The in 1999 and the Aid flow from UN agencies (US$) in Marshall Islands in 2002?
Your answer should be very brief. 1.52e+06. What is the difference between the Aid flow from UN agencies (US$) of High income in 2000 and the Aid flow from UN agencies (US$) of Belize in 2001?
Offer a terse response. 1.52e+07. What is the difference between the Aid flow from UN agencies (US$) in High income in 2000 and the Aid flow from UN agencies (US$) in Gambia, The in 2001?
Provide a succinct answer. 1.47e+07. What is the difference between the Aid flow from UN agencies (US$) of High income in 2000 and the Aid flow from UN agencies (US$) of Marshall Islands in 2001?
Your answer should be very brief. 1.56e+07. What is the difference between the Aid flow from UN agencies (US$) of Belize in 2000 and the Aid flow from UN agencies (US$) of Gambia, The in 2001?
Give a very brief answer. -5.50e+05. What is the difference between the Aid flow from UN agencies (US$) in Belize in 2000 and the Aid flow from UN agencies (US$) in Marshall Islands in 2001?
Give a very brief answer. 3.70e+05. What is the difference between the Aid flow from UN agencies (US$) of Gambia, The in 2000 and the Aid flow from UN agencies (US$) of Marshall Islands in 2001?
Your answer should be very brief. 1.85e+06. What is the difference between the Aid flow from UN agencies (US$) in High income in 2000 and the Aid flow from UN agencies (US$) in Belize in 2002?
Offer a terse response. 1.51e+07. What is the difference between the Aid flow from UN agencies (US$) of High income in 2000 and the Aid flow from UN agencies (US$) of Gambia, The in 2002?
Provide a succinct answer. 1.39e+07. What is the difference between the Aid flow from UN agencies (US$) in High income in 2000 and the Aid flow from UN agencies (US$) in Marshall Islands in 2002?
Provide a short and direct response. 1.58e+07. What is the difference between the Aid flow from UN agencies (US$) of Belize in 2000 and the Aid flow from UN agencies (US$) of Gambia, The in 2002?
Your answer should be compact. -1.37e+06. What is the difference between the Aid flow from UN agencies (US$) in Gambia, The in 2000 and the Aid flow from UN agencies (US$) in Marshall Islands in 2002?
Provide a short and direct response. 1.96e+06. What is the difference between the Aid flow from UN agencies (US$) of High income in 2001 and the Aid flow from UN agencies (US$) of Belize in 2002?
Give a very brief answer. 1.23e+07. What is the difference between the Aid flow from UN agencies (US$) of High income in 2001 and the Aid flow from UN agencies (US$) of Gambia, The in 2002?
Offer a terse response. 1.11e+07. What is the difference between the Aid flow from UN agencies (US$) in High income in 2001 and the Aid flow from UN agencies (US$) in Marshall Islands in 2002?
Your response must be concise. 1.29e+07. What is the difference between the Aid flow from UN agencies (US$) in Belize in 2001 and the Aid flow from UN agencies (US$) in Gambia, The in 2002?
Your answer should be very brief. -1.30e+06. What is the difference between the Aid flow from UN agencies (US$) in Belize in 2001 and the Aid flow from UN agencies (US$) in Marshall Islands in 2002?
Your answer should be very brief. 5.50e+05. What is the difference between the Aid flow from UN agencies (US$) in Gambia, The in 2001 and the Aid flow from UN agencies (US$) in Marshall Islands in 2002?
Your answer should be very brief. 1.03e+06. What is the average Aid flow from UN agencies (US$) of High income per year?
Your answer should be compact. 1.53e+07. What is the average Aid flow from UN agencies (US$) of Gambia, The per year?
Keep it short and to the point. 1.56e+06. What is the average Aid flow from UN agencies (US$) of Marshall Islands per year?
Give a very brief answer. 1.52e+05. In the year 1995, what is the difference between the Aid flow from UN agencies (US$) of High income and Aid flow from UN agencies (US$) of Belize?
Make the answer very short. 1.91e+07. In the year 1995, what is the difference between the Aid flow from UN agencies (US$) of High income and Aid flow from UN agencies (US$) of Gambia, The?
Provide a short and direct response. 1.78e+07. In the year 1995, what is the difference between the Aid flow from UN agencies (US$) in High income and Aid flow from UN agencies (US$) in Marshall Islands?
Provide a short and direct response. 1.96e+07. In the year 1995, what is the difference between the Aid flow from UN agencies (US$) in Belize and Aid flow from UN agencies (US$) in Gambia, The?
Provide a succinct answer. -1.36e+06. In the year 1995, what is the difference between the Aid flow from UN agencies (US$) of Belize and Aid flow from UN agencies (US$) of Marshall Islands?
Provide a short and direct response. 5.20e+05. In the year 1995, what is the difference between the Aid flow from UN agencies (US$) in Gambia, The and Aid flow from UN agencies (US$) in Marshall Islands?
Ensure brevity in your answer.  1.88e+06. In the year 1996, what is the difference between the Aid flow from UN agencies (US$) of High income and Aid flow from UN agencies (US$) of Belize?
Give a very brief answer. 1.14e+07. In the year 1996, what is the difference between the Aid flow from UN agencies (US$) of High income and Aid flow from UN agencies (US$) of Gambia, The?
Provide a short and direct response. 1.09e+07. In the year 1996, what is the difference between the Aid flow from UN agencies (US$) of High income and Aid flow from UN agencies (US$) of Marshall Islands?
Provide a short and direct response. 1.16e+07. In the year 1996, what is the difference between the Aid flow from UN agencies (US$) of Belize and Aid flow from UN agencies (US$) of Gambia, The?
Offer a terse response. -5.10e+05. In the year 1996, what is the difference between the Aid flow from UN agencies (US$) of Gambia, The and Aid flow from UN agencies (US$) of Marshall Islands?
Keep it short and to the point. 7.20e+05. In the year 1997, what is the difference between the Aid flow from UN agencies (US$) in High income and Aid flow from UN agencies (US$) in Belize?
Your answer should be very brief. 1.54e+07. In the year 1997, what is the difference between the Aid flow from UN agencies (US$) in High income and Aid flow from UN agencies (US$) in Gambia, The?
Ensure brevity in your answer.  1.42e+07. In the year 1997, what is the difference between the Aid flow from UN agencies (US$) in High income and Aid flow from UN agencies (US$) in Marshall Islands?
Your response must be concise. 1.57e+07. In the year 1997, what is the difference between the Aid flow from UN agencies (US$) in Belize and Aid flow from UN agencies (US$) in Gambia, The?
Ensure brevity in your answer.  -1.20e+06. In the year 1997, what is the difference between the Aid flow from UN agencies (US$) in Belize and Aid flow from UN agencies (US$) in Marshall Islands?
Your answer should be very brief. 2.90e+05. In the year 1997, what is the difference between the Aid flow from UN agencies (US$) of Gambia, The and Aid flow from UN agencies (US$) of Marshall Islands?
Give a very brief answer. 1.49e+06. In the year 1998, what is the difference between the Aid flow from UN agencies (US$) of High income and Aid flow from UN agencies (US$) of Belize?
Your answer should be compact. 1.39e+07. In the year 1998, what is the difference between the Aid flow from UN agencies (US$) in High income and Aid flow from UN agencies (US$) in Gambia, The?
Give a very brief answer. 1.31e+07. In the year 1998, what is the difference between the Aid flow from UN agencies (US$) of High income and Aid flow from UN agencies (US$) of Marshall Islands?
Give a very brief answer. 1.41e+07. In the year 1998, what is the difference between the Aid flow from UN agencies (US$) of Belize and Aid flow from UN agencies (US$) of Gambia, The?
Offer a terse response. -7.70e+05. In the year 1998, what is the difference between the Aid flow from UN agencies (US$) of Belize and Aid flow from UN agencies (US$) of Marshall Islands?
Offer a terse response. 2.50e+05. In the year 1998, what is the difference between the Aid flow from UN agencies (US$) of Gambia, The and Aid flow from UN agencies (US$) of Marshall Islands?
Your answer should be compact. 1.02e+06. In the year 1999, what is the difference between the Aid flow from UN agencies (US$) of High income and Aid flow from UN agencies (US$) of Belize?
Ensure brevity in your answer.  1.75e+07. In the year 1999, what is the difference between the Aid flow from UN agencies (US$) in High income and Aid flow from UN agencies (US$) in Gambia, The?
Make the answer very short. 1.64e+07. In the year 1999, what is the difference between the Aid flow from UN agencies (US$) in High income and Aid flow from UN agencies (US$) in Marshall Islands?
Your answer should be compact. 1.79e+07. In the year 1999, what is the difference between the Aid flow from UN agencies (US$) of Belize and Aid flow from UN agencies (US$) of Gambia, The?
Give a very brief answer. -1.03e+06. In the year 1999, what is the difference between the Aid flow from UN agencies (US$) of Gambia, The and Aid flow from UN agencies (US$) of Marshall Islands?
Ensure brevity in your answer.  1.45e+06. In the year 2000, what is the difference between the Aid flow from UN agencies (US$) of High income and Aid flow from UN agencies (US$) of Belize?
Your answer should be compact. 1.53e+07. In the year 2000, what is the difference between the Aid flow from UN agencies (US$) of High income and Aid flow from UN agencies (US$) of Gambia, The?
Provide a succinct answer. 1.38e+07. In the year 2000, what is the difference between the Aid flow from UN agencies (US$) in High income and Aid flow from UN agencies (US$) in Marshall Islands?
Offer a very short reply. 1.57e+07. In the year 2000, what is the difference between the Aid flow from UN agencies (US$) in Belize and Aid flow from UN agencies (US$) in Gambia, The?
Your response must be concise. -1.48e+06. In the year 2000, what is the difference between the Aid flow from UN agencies (US$) in Belize and Aid flow from UN agencies (US$) in Marshall Islands?
Your response must be concise. 4.30e+05. In the year 2000, what is the difference between the Aid flow from UN agencies (US$) in Gambia, The and Aid flow from UN agencies (US$) in Marshall Islands?
Your response must be concise. 1.91e+06. In the year 2001, what is the difference between the Aid flow from UN agencies (US$) of High income and Aid flow from UN agencies (US$) of Belize?
Your answer should be compact. 1.24e+07. In the year 2001, what is the difference between the Aid flow from UN agencies (US$) of High income and Aid flow from UN agencies (US$) of Gambia, The?
Your answer should be very brief. 1.19e+07. In the year 2001, what is the difference between the Aid flow from UN agencies (US$) in High income and Aid flow from UN agencies (US$) in Marshall Islands?
Offer a terse response. 1.28e+07. In the year 2001, what is the difference between the Aid flow from UN agencies (US$) in Belize and Aid flow from UN agencies (US$) in Gambia, The?
Provide a short and direct response. -4.80e+05. In the year 2001, what is the difference between the Aid flow from UN agencies (US$) of Belize and Aid flow from UN agencies (US$) of Marshall Islands?
Ensure brevity in your answer.  4.40e+05. In the year 2001, what is the difference between the Aid flow from UN agencies (US$) of Gambia, The and Aid flow from UN agencies (US$) of Marshall Islands?
Your answer should be compact. 9.20e+05. In the year 2002, what is the difference between the Aid flow from UN agencies (US$) in High income and Aid flow from UN agencies (US$) in Belize?
Your response must be concise. 1.28e+07. In the year 2002, what is the difference between the Aid flow from UN agencies (US$) of High income and Aid flow from UN agencies (US$) of Gambia, The?
Provide a succinct answer. 1.16e+07. In the year 2002, what is the difference between the Aid flow from UN agencies (US$) of High income and Aid flow from UN agencies (US$) of Marshall Islands?
Provide a succinct answer. 1.34e+07. In the year 2002, what is the difference between the Aid flow from UN agencies (US$) of Belize and Aid flow from UN agencies (US$) of Gambia, The?
Your answer should be very brief. -1.23e+06. In the year 2002, what is the difference between the Aid flow from UN agencies (US$) of Belize and Aid flow from UN agencies (US$) of Marshall Islands?
Offer a very short reply. 6.20e+05. In the year 2002, what is the difference between the Aid flow from UN agencies (US$) of Gambia, The and Aid flow from UN agencies (US$) of Marshall Islands?
Offer a terse response. 1.85e+06. What is the ratio of the Aid flow from UN agencies (US$) in High income in 1995 to that in 1996?
Offer a very short reply. 1.7. What is the ratio of the Aid flow from UN agencies (US$) in Belize in 1995 to that in 1996?
Your response must be concise. 2.39. What is the ratio of the Aid flow from UN agencies (US$) of Gambia, The in 1995 to that in 1996?
Give a very brief answer. 2.56. What is the ratio of the Aid flow from UN agencies (US$) in Marshall Islands in 1995 to that in 1996?
Provide a short and direct response. 2.2. What is the ratio of the Aid flow from UN agencies (US$) in High income in 1995 to that in 1997?
Make the answer very short. 1.25. What is the ratio of the Aid flow from UN agencies (US$) in Belize in 1995 to that in 1997?
Offer a very short reply. 1.72. What is the ratio of the Aid flow from UN agencies (US$) of Gambia, The in 1995 to that in 1997?
Provide a succinct answer. 1.29. What is the ratio of the Aid flow from UN agencies (US$) in Marshall Islands in 1995 to that in 1997?
Keep it short and to the point. 1.57. What is the ratio of the Aid flow from UN agencies (US$) of High income in 1995 to that in 1998?
Offer a terse response. 1.39. What is the ratio of the Aid flow from UN agencies (US$) in Belize in 1995 to that in 1998?
Offer a very short reply. 1.76. What is the ratio of the Aid flow from UN agencies (US$) of Gambia, The in 1995 to that in 1998?
Keep it short and to the point. 1.76. What is the ratio of the Aid flow from UN agencies (US$) in Marshall Islands in 1995 to that in 1998?
Give a very brief answer. 1.29. What is the ratio of the Aid flow from UN agencies (US$) of High income in 1995 to that in 1999?
Give a very brief answer. 1.1. What is the ratio of the Aid flow from UN agencies (US$) in Belize in 1995 to that in 1999?
Offer a very short reply. 1.28. What is the ratio of the Aid flow from UN agencies (US$) in Gambia, The in 1995 to that in 1999?
Provide a short and direct response. 1.3. What is the ratio of the Aid flow from UN agencies (US$) in Marshall Islands in 1995 to that in 1999?
Your response must be concise. 1.38. What is the ratio of the Aid flow from UN agencies (US$) of High income in 1995 to that in 2000?
Your answer should be compact. 1.25. What is the ratio of the Aid flow from UN agencies (US$) of Belize in 1995 to that in 2000?
Offer a very short reply. 1.3. What is the ratio of the Aid flow from UN agencies (US$) in Gambia, The in 1995 to that in 2000?
Ensure brevity in your answer.  1.02. What is the ratio of the Aid flow from UN agencies (US$) of Marshall Islands in 1995 to that in 2000?
Offer a terse response. 1.57. What is the ratio of the Aid flow from UN agencies (US$) of High income in 1995 to that in 2001?
Your response must be concise. 1.52. What is the ratio of the Aid flow from UN agencies (US$) in Belize in 1995 to that in 2001?
Provide a succinct answer. 1.16. What is the ratio of the Aid flow from UN agencies (US$) in Gambia, The in 1995 to that in 2001?
Offer a terse response. 1.88. What is the ratio of the Aid flow from UN agencies (US$) in Marshall Islands in 1995 to that in 2001?
Keep it short and to the point. 1.1. What is the ratio of the Aid flow from UN agencies (US$) of High income in 1995 to that in 2002?
Provide a succinct answer. 1.47. What is the ratio of the Aid flow from UN agencies (US$) in Belize in 1995 to that in 2002?
Provide a succinct answer. 1.04. What is the ratio of the Aid flow from UN agencies (US$) in Gambia, The in 1995 to that in 2002?
Offer a terse response. 1.08. What is the ratio of the Aid flow from UN agencies (US$) in Marshall Islands in 1995 to that in 2002?
Make the answer very short. 2.44. What is the ratio of the Aid flow from UN agencies (US$) in High income in 1996 to that in 1997?
Your response must be concise. 0.74. What is the ratio of the Aid flow from UN agencies (US$) in Belize in 1996 to that in 1997?
Provide a succinct answer. 0.72. What is the ratio of the Aid flow from UN agencies (US$) in Gambia, The in 1996 to that in 1997?
Your response must be concise. 0.5. What is the ratio of the Aid flow from UN agencies (US$) of Marshall Islands in 1996 to that in 1997?
Keep it short and to the point. 0.71. What is the ratio of the Aid flow from UN agencies (US$) of High income in 1996 to that in 1998?
Your response must be concise. 0.82. What is the ratio of the Aid flow from UN agencies (US$) of Belize in 1996 to that in 1998?
Offer a very short reply. 0.74. What is the ratio of the Aid flow from UN agencies (US$) in Gambia, The in 1996 to that in 1998?
Give a very brief answer. 0.69. What is the ratio of the Aid flow from UN agencies (US$) in Marshall Islands in 1996 to that in 1998?
Provide a succinct answer. 0.59. What is the ratio of the Aid flow from UN agencies (US$) of High income in 1996 to that in 1999?
Provide a short and direct response. 0.65. What is the ratio of the Aid flow from UN agencies (US$) in Belize in 1996 to that in 1999?
Your answer should be very brief. 0.53. What is the ratio of the Aid flow from UN agencies (US$) in Gambia, The in 1996 to that in 1999?
Make the answer very short. 0.51. What is the ratio of the Aid flow from UN agencies (US$) in High income in 1996 to that in 2000?
Keep it short and to the point. 0.74. What is the ratio of the Aid flow from UN agencies (US$) of Belize in 1996 to that in 2000?
Your answer should be compact. 0.54. What is the ratio of the Aid flow from UN agencies (US$) in Gambia, The in 1996 to that in 2000?
Keep it short and to the point. 0.4. What is the ratio of the Aid flow from UN agencies (US$) in High income in 1996 to that in 2001?
Your answer should be compact. 0.9. What is the ratio of the Aid flow from UN agencies (US$) in Belize in 1996 to that in 2001?
Provide a succinct answer. 0.48. What is the ratio of the Aid flow from UN agencies (US$) of Gambia, The in 1996 to that in 2001?
Make the answer very short. 0.73. What is the ratio of the Aid flow from UN agencies (US$) in Marshall Islands in 1996 to that in 2001?
Your answer should be compact. 0.5. What is the ratio of the Aid flow from UN agencies (US$) of High income in 1996 to that in 2002?
Offer a very short reply. 0.87. What is the ratio of the Aid flow from UN agencies (US$) of Belize in 1996 to that in 2002?
Your answer should be very brief. 0.44. What is the ratio of the Aid flow from UN agencies (US$) of Gambia, The in 1996 to that in 2002?
Keep it short and to the point. 0.42. What is the ratio of the Aid flow from UN agencies (US$) of High income in 1997 to that in 1998?
Your answer should be very brief. 1.11. What is the ratio of the Aid flow from UN agencies (US$) of Belize in 1997 to that in 1998?
Offer a very short reply. 1.02. What is the ratio of the Aid flow from UN agencies (US$) in Gambia, The in 1997 to that in 1998?
Provide a short and direct response. 1.37. What is the ratio of the Aid flow from UN agencies (US$) in Marshall Islands in 1997 to that in 1998?
Offer a very short reply. 0.82. What is the ratio of the Aid flow from UN agencies (US$) in High income in 1997 to that in 1999?
Offer a terse response. 0.88. What is the ratio of the Aid flow from UN agencies (US$) of Belize in 1997 to that in 1999?
Your answer should be very brief. 0.74. What is the ratio of the Aid flow from UN agencies (US$) of Gambia, The in 1997 to that in 1999?
Your response must be concise. 1.01. What is the ratio of the Aid flow from UN agencies (US$) of Marshall Islands in 1997 to that in 1999?
Keep it short and to the point. 0.88. What is the ratio of the Aid flow from UN agencies (US$) in High income in 1997 to that in 2000?
Ensure brevity in your answer.  1. What is the ratio of the Aid flow from UN agencies (US$) of Belize in 1997 to that in 2000?
Give a very brief answer. 0.75. What is the ratio of the Aid flow from UN agencies (US$) in Gambia, The in 1997 to that in 2000?
Give a very brief answer. 0.8. What is the ratio of the Aid flow from UN agencies (US$) in Marshall Islands in 1997 to that in 2000?
Offer a very short reply. 1. What is the ratio of the Aid flow from UN agencies (US$) in High income in 1997 to that in 2001?
Ensure brevity in your answer.  1.22. What is the ratio of the Aid flow from UN agencies (US$) in Belize in 1997 to that in 2001?
Your response must be concise. 0.67. What is the ratio of the Aid flow from UN agencies (US$) in Gambia, The in 1997 to that in 2001?
Offer a terse response. 1.46. What is the ratio of the Aid flow from UN agencies (US$) in High income in 1997 to that in 2002?
Provide a succinct answer. 1.17. What is the ratio of the Aid flow from UN agencies (US$) of Belize in 1997 to that in 2002?
Ensure brevity in your answer.  0.61. What is the ratio of the Aid flow from UN agencies (US$) in Gambia, The in 1997 to that in 2002?
Offer a very short reply. 0.84. What is the ratio of the Aid flow from UN agencies (US$) in Marshall Islands in 1997 to that in 2002?
Give a very brief answer. 1.56. What is the ratio of the Aid flow from UN agencies (US$) in High income in 1998 to that in 1999?
Offer a terse response. 0.79. What is the ratio of the Aid flow from UN agencies (US$) in Belize in 1998 to that in 1999?
Your response must be concise. 0.72. What is the ratio of the Aid flow from UN agencies (US$) in Gambia, The in 1998 to that in 1999?
Make the answer very short. 0.74. What is the ratio of the Aid flow from UN agencies (US$) in Marshall Islands in 1998 to that in 1999?
Offer a terse response. 1.06. What is the ratio of the Aid flow from UN agencies (US$) of High income in 1998 to that in 2000?
Provide a succinct answer. 0.9. What is the ratio of the Aid flow from UN agencies (US$) of Belize in 1998 to that in 2000?
Ensure brevity in your answer.  0.74. What is the ratio of the Aid flow from UN agencies (US$) in Gambia, The in 1998 to that in 2000?
Provide a short and direct response. 0.58. What is the ratio of the Aid flow from UN agencies (US$) in Marshall Islands in 1998 to that in 2000?
Make the answer very short. 1.21. What is the ratio of the Aid flow from UN agencies (US$) in High income in 1998 to that in 2001?
Provide a short and direct response. 1.1. What is the ratio of the Aid flow from UN agencies (US$) in Belize in 1998 to that in 2001?
Ensure brevity in your answer.  0.66. What is the ratio of the Aid flow from UN agencies (US$) of Gambia, The in 1998 to that in 2001?
Provide a succinct answer. 1.06. What is the ratio of the Aid flow from UN agencies (US$) in Marshall Islands in 1998 to that in 2001?
Ensure brevity in your answer.  0.85. What is the ratio of the Aid flow from UN agencies (US$) in High income in 1998 to that in 2002?
Keep it short and to the point. 1.06. What is the ratio of the Aid flow from UN agencies (US$) in Belize in 1998 to that in 2002?
Give a very brief answer. 0.59. What is the ratio of the Aid flow from UN agencies (US$) of Gambia, The in 1998 to that in 2002?
Offer a very short reply. 0.61. What is the ratio of the Aid flow from UN agencies (US$) of Marshall Islands in 1998 to that in 2002?
Your response must be concise. 1.89. What is the ratio of the Aid flow from UN agencies (US$) in High income in 1999 to that in 2000?
Your answer should be compact. 1.14. What is the ratio of the Aid flow from UN agencies (US$) of Belize in 1999 to that in 2000?
Your response must be concise. 1.02. What is the ratio of the Aid flow from UN agencies (US$) in Gambia, The in 1999 to that in 2000?
Offer a terse response. 0.79. What is the ratio of the Aid flow from UN agencies (US$) in High income in 1999 to that in 2001?
Give a very brief answer. 1.39. What is the ratio of the Aid flow from UN agencies (US$) in Belize in 1999 to that in 2001?
Keep it short and to the point. 0.91. What is the ratio of the Aid flow from UN agencies (US$) of Gambia, The in 1999 to that in 2001?
Give a very brief answer. 1.44. What is the ratio of the Aid flow from UN agencies (US$) of High income in 1999 to that in 2002?
Keep it short and to the point. 1.34. What is the ratio of the Aid flow from UN agencies (US$) of Belize in 1999 to that in 2002?
Your answer should be very brief. 0.82. What is the ratio of the Aid flow from UN agencies (US$) in Gambia, The in 1999 to that in 2002?
Make the answer very short. 0.83. What is the ratio of the Aid flow from UN agencies (US$) of Marshall Islands in 1999 to that in 2002?
Your answer should be compact. 1.78. What is the ratio of the Aid flow from UN agencies (US$) in High income in 2000 to that in 2001?
Provide a succinct answer. 1.22. What is the ratio of the Aid flow from UN agencies (US$) in Belize in 2000 to that in 2001?
Your answer should be very brief. 0.89. What is the ratio of the Aid flow from UN agencies (US$) of Gambia, The in 2000 to that in 2001?
Offer a very short reply. 1.83. What is the ratio of the Aid flow from UN agencies (US$) of Marshall Islands in 2000 to that in 2001?
Ensure brevity in your answer.  0.7. What is the ratio of the Aid flow from UN agencies (US$) of High income in 2000 to that in 2002?
Keep it short and to the point. 1.17. What is the ratio of the Aid flow from UN agencies (US$) in Belize in 2000 to that in 2002?
Your answer should be very brief. 0.8. What is the ratio of the Aid flow from UN agencies (US$) in Gambia, The in 2000 to that in 2002?
Give a very brief answer. 1.06. What is the ratio of the Aid flow from UN agencies (US$) in Marshall Islands in 2000 to that in 2002?
Your answer should be very brief. 1.56. What is the ratio of the Aid flow from UN agencies (US$) of High income in 2001 to that in 2002?
Provide a short and direct response. 0.97. What is the ratio of the Aid flow from UN agencies (US$) in Belize in 2001 to that in 2002?
Keep it short and to the point. 0.9. What is the ratio of the Aid flow from UN agencies (US$) in Gambia, The in 2001 to that in 2002?
Make the answer very short. 0.58. What is the ratio of the Aid flow from UN agencies (US$) in Marshall Islands in 2001 to that in 2002?
Provide a short and direct response. 2.22. What is the difference between the highest and the second highest Aid flow from UN agencies (US$) of High income?
Your response must be concise. 1.81e+06. What is the difference between the highest and the second highest Aid flow from UN agencies (US$) in Belize?
Your answer should be very brief. 3.00e+04. What is the difference between the highest and the second highest Aid flow from UN agencies (US$) of Gambia, The?
Your answer should be very brief. 5.00e+04. What is the difference between the highest and the second highest Aid flow from UN agencies (US$) of Marshall Islands?
Ensure brevity in your answer.  2.00e+04. What is the difference between the highest and the lowest Aid flow from UN agencies (US$) of High income?
Ensure brevity in your answer.  8.16e+06. What is the difference between the highest and the lowest Aid flow from UN agencies (US$) in Belize?
Provide a succinct answer. 4.30e+05. What is the difference between the highest and the lowest Aid flow from UN agencies (US$) in Gambia, The?
Ensure brevity in your answer.  1.28e+06. 